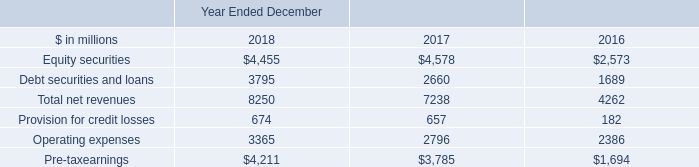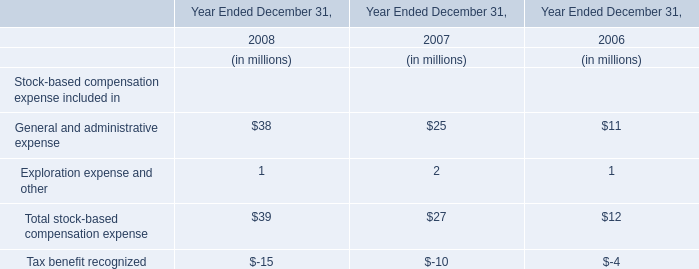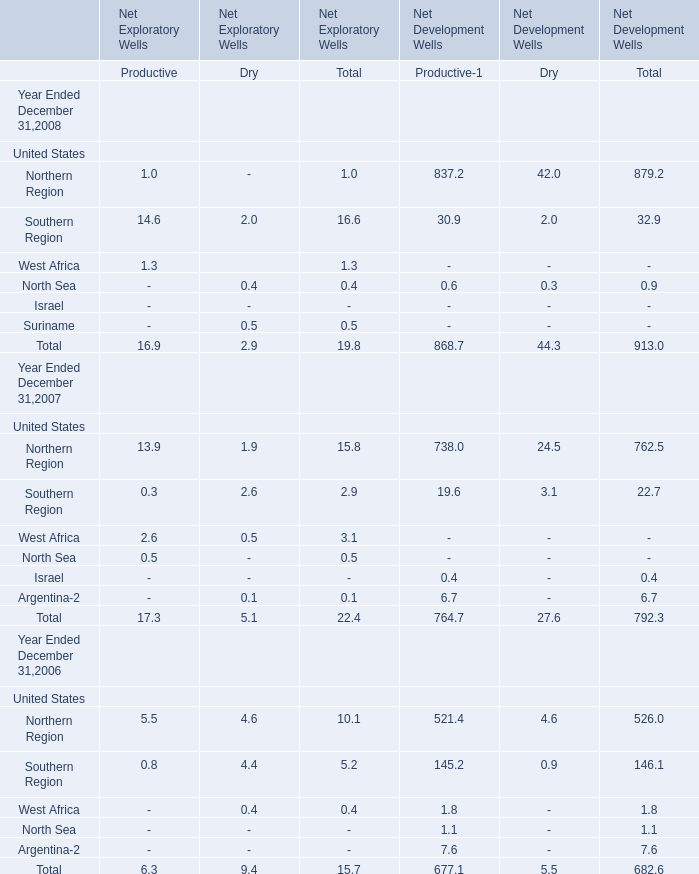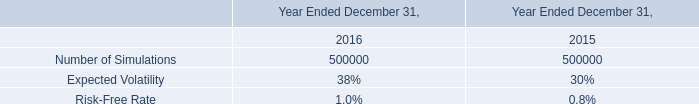If Northern Region for Total of Net Development Wells develops with the same growth rate in 2008, what will it reach in 2009? 
Computations: (879.2 * (1 + ((879.2 - 762.5) / 762.5)))
Answer: 1013.76084. 